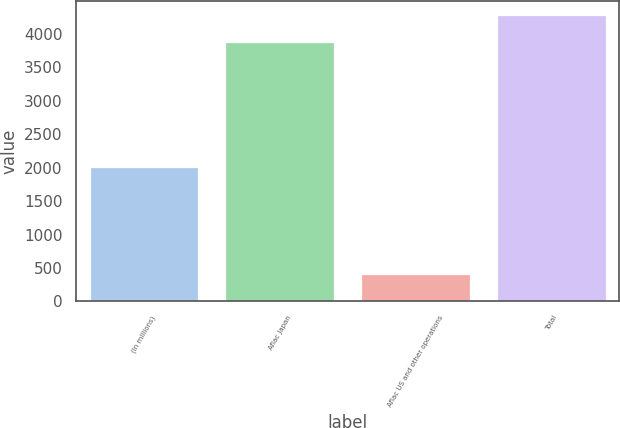<chart> <loc_0><loc_0><loc_500><loc_500><bar_chart><fcel>(In millions)<fcel>Aflac Japan<fcel>Aflac US and other operations<fcel>Total<nl><fcel>2008<fcel>3874<fcel>409<fcel>4283<nl></chart> 